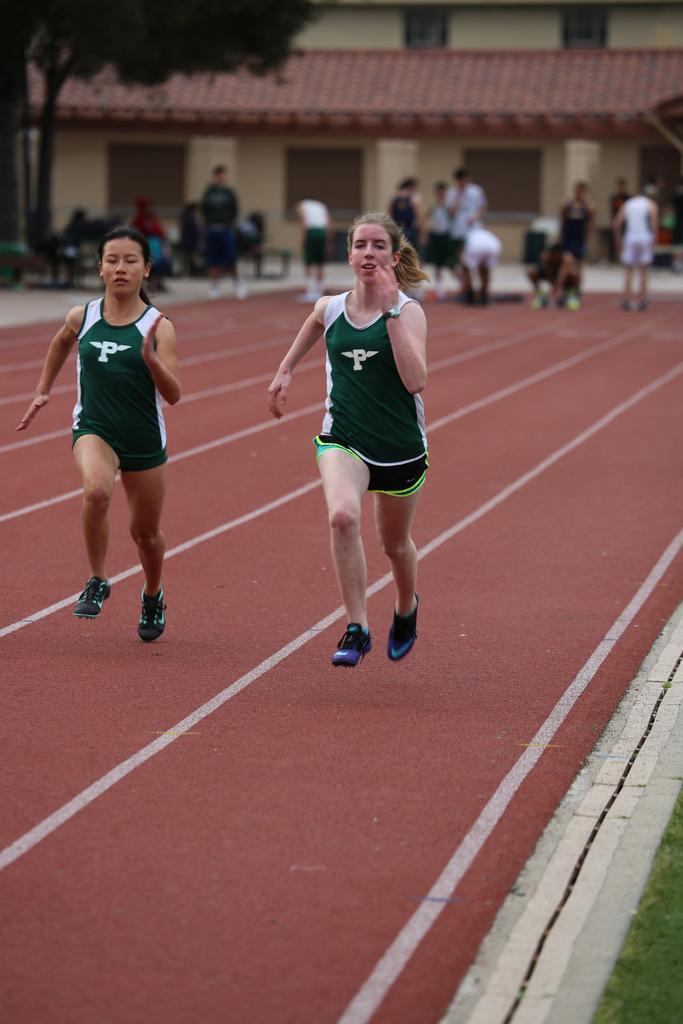In one or two sentences, can you explain what this image depicts? This picture describes about group of people, few people are standing, few are seated and two women are running, in the background we can see a house and trees. 